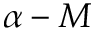Convert formula to latex. <formula><loc_0><loc_0><loc_500><loc_500>\alpha - M</formula> 